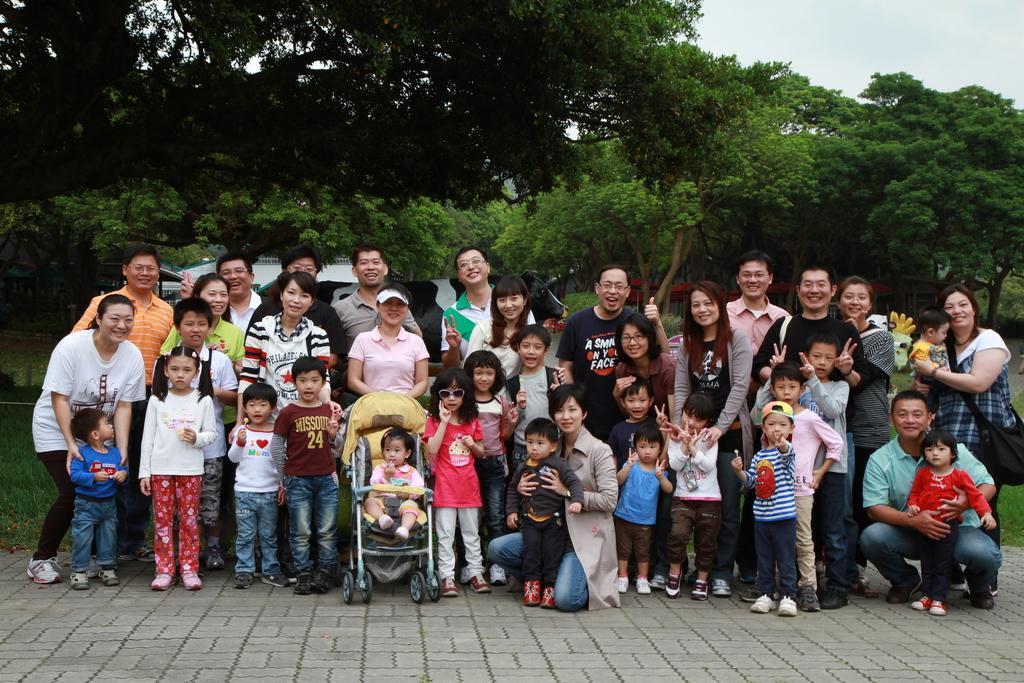Please provide a concise description of this image. In this picture I can see the number of people standing on the floor with smiles. I can see a kid on the wheel cradle. I can see green grass. I can see trees in the background. I can see clouds in the sky. 